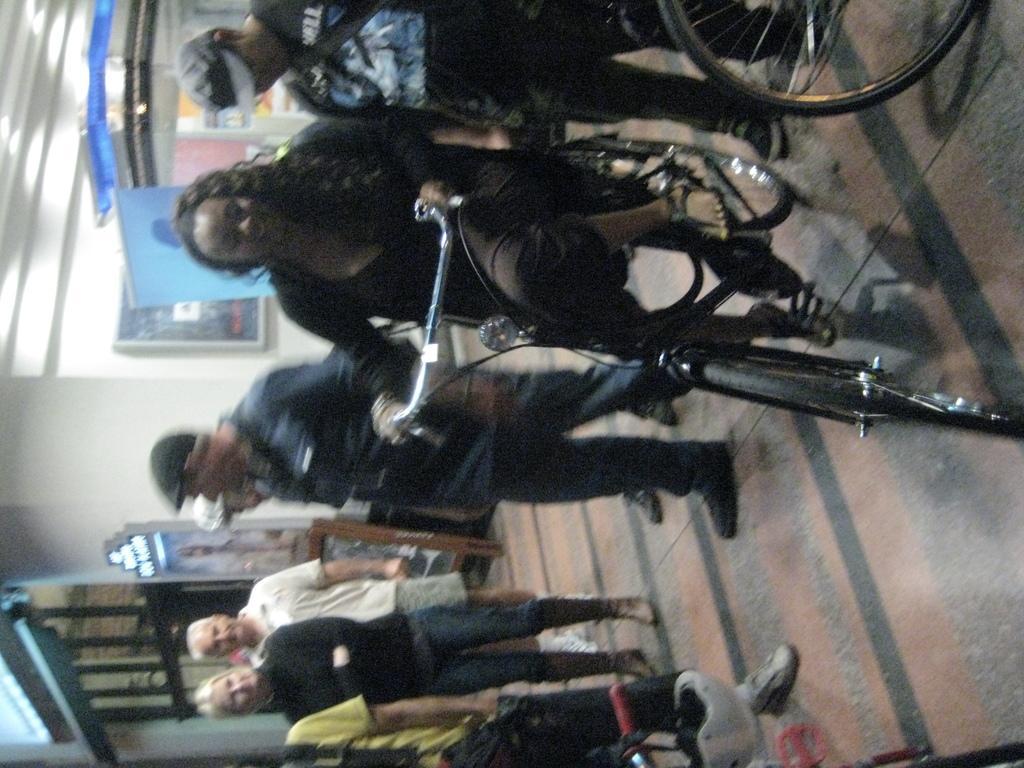Describe this image in one or two sentences. In this image I can see group of people standing. In front I can see the person riding the bicycle. In the background I can see few stalls and the wall is in white color. 